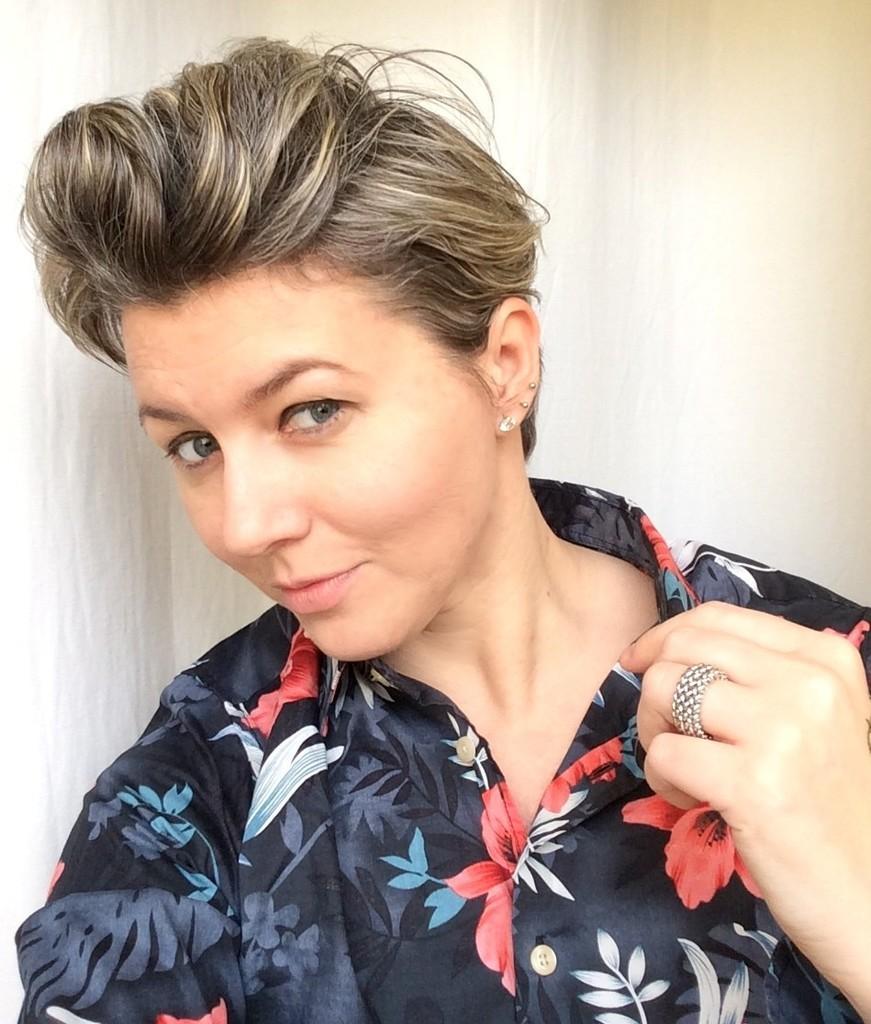Could you give a brief overview of what you see in this image? In the picture we can see a woman in a black shirt and some designs on it and she is holding her color in her hand and behind her we can see the wall. 